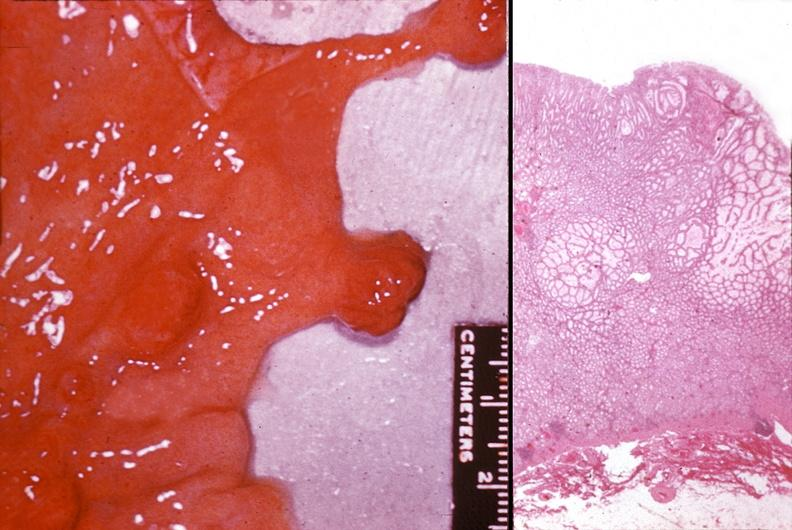what does this image show?
Answer the question using a single word or phrase. Stomach 